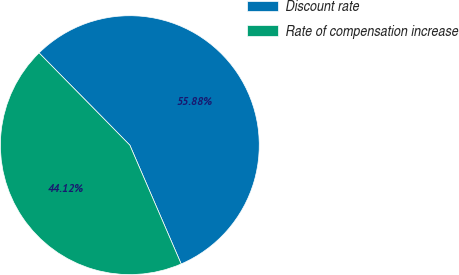Convert chart. <chart><loc_0><loc_0><loc_500><loc_500><pie_chart><fcel>Discount rate<fcel>Rate of compensation increase<nl><fcel>55.88%<fcel>44.12%<nl></chart> 